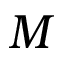<formula> <loc_0><loc_0><loc_500><loc_500>M</formula> 